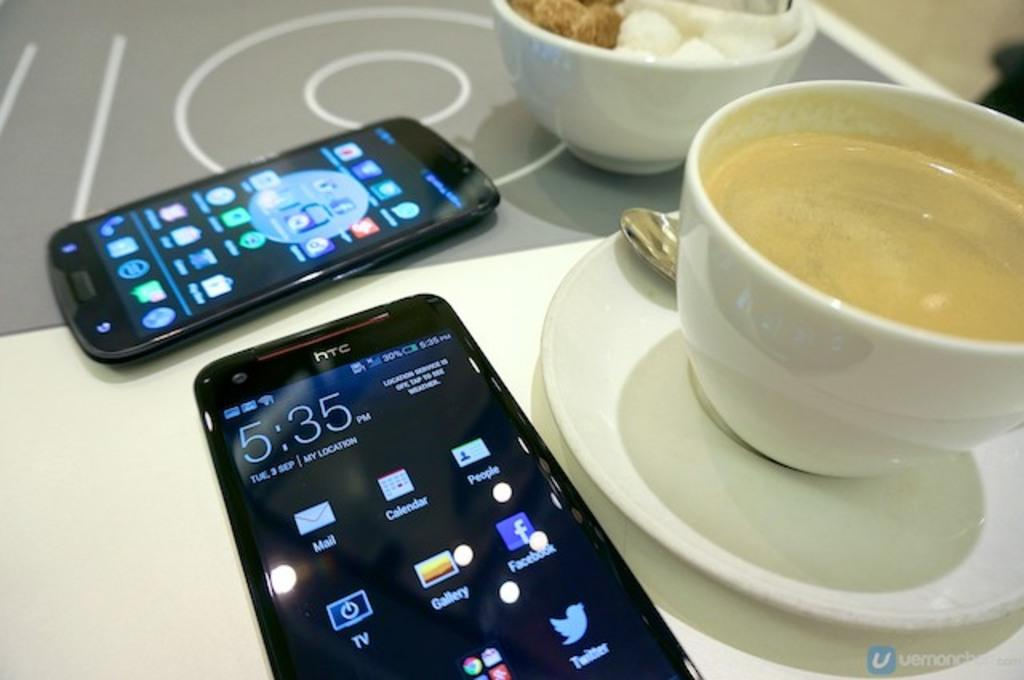Provide a one-sentence caption for the provided image. Two phones, one branded HTC, sit on a table with cups of coffee. 